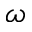<formula> <loc_0><loc_0><loc_500><loc_500>\omega</formula> 